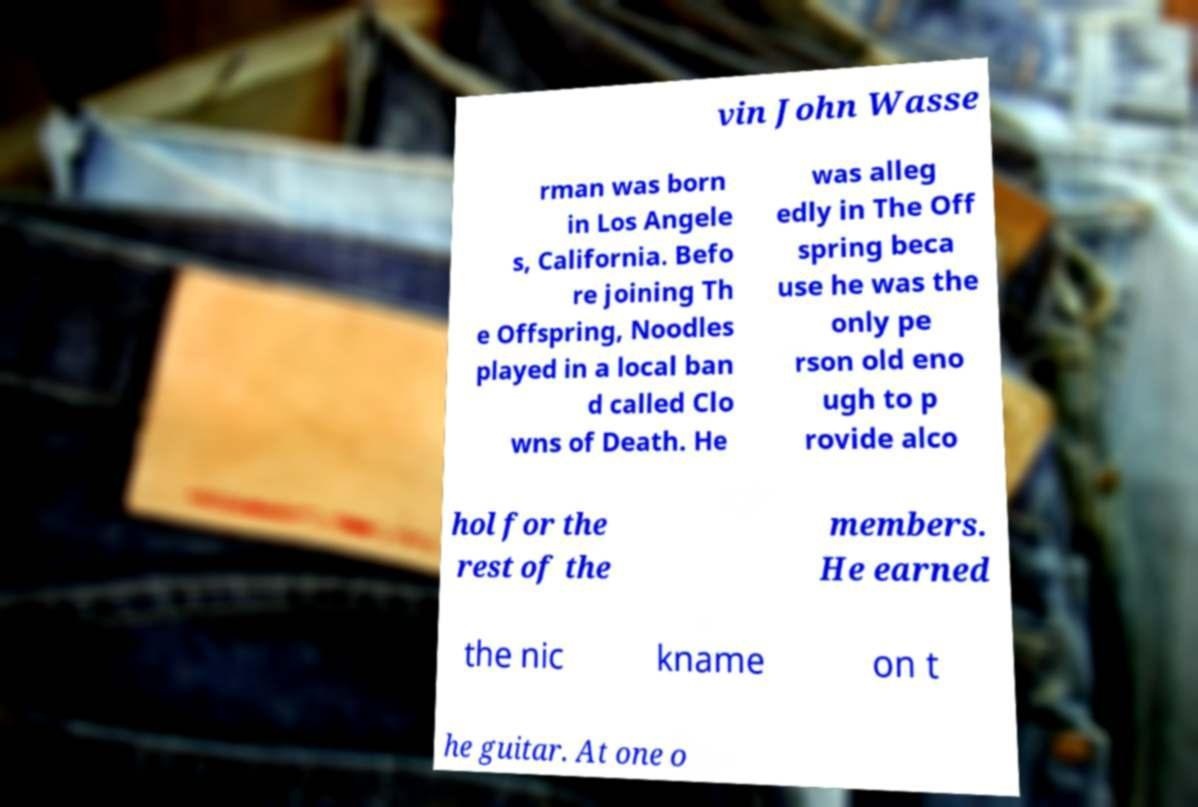Can you read and provide the text displayed in the image?This photo seems to have some interesting text. Can you extract and type it out for me? vin John Wasse rman was born in Los Angele s, California. Befo re joining Th e Offspring, Noodles played in a local ban d called Clo wns of Death. He was alleg edly in The Off spring beca use he was the only pe rson old eno ugh to p rovide alco hol for the rest of the members. He earned the nic kname on t he guitar. At one o 